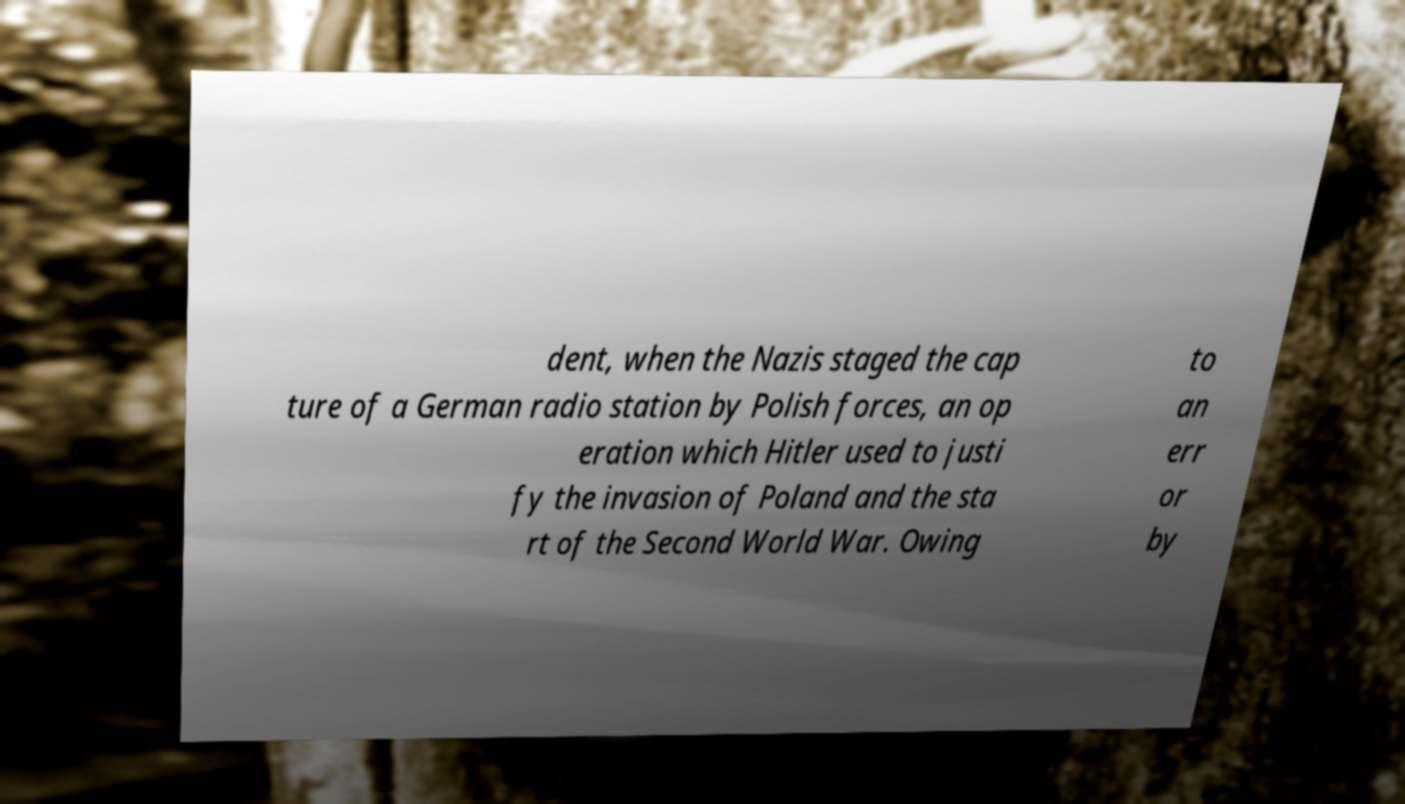For documentation purposes, I need the text within this image transcribed. Could you provide that? dent, when the Nazis staged the cap ture of a German radio station by Polish forces, an op eration which Hitler used to justi fy the invasion of Poland and the sta rt of the Second World War. Owing to an err or by 